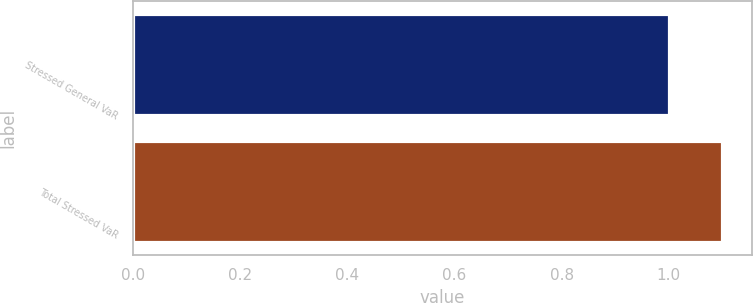Convert chart. <chart><loc_0><loc_0><loc_500><loc_500><bar_chart><fcel>Stressed General VaR<fcel>Total Stressed VaR<nl><fcel>1<fcel>1.1<nl></chart> 